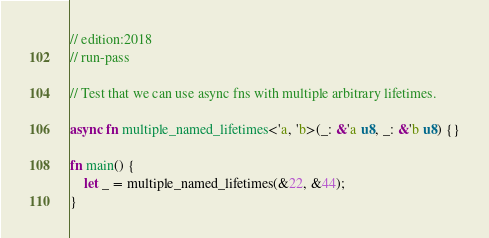Convert code to text. <code><loc_0><loc_0><loc_500><loc_500><_Rust_>// edition:2018
// run-pass

// Test that we can use async fns with multiple arbitrary lifetimes.

async fn multiple_named_lifetimes<'a, 'b>(_: &'a u8, _: &'b u8) {}

fn main() {
    let _ = multiple_named_lifetimes(&22, &44);
}
</code> 